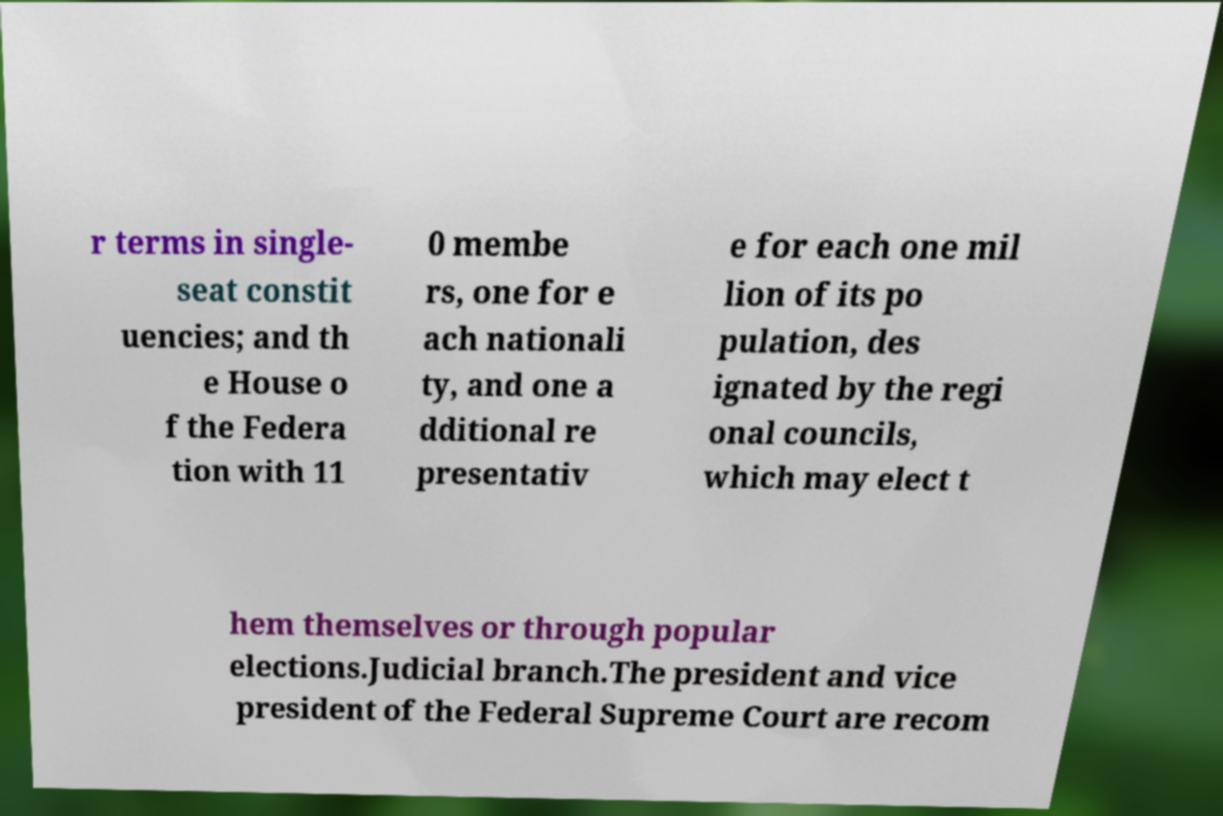Could you extract and type out the text from this image? r terms in single- seat constit uencies; and th e House o f the Federa tion with 11 0 membe rs, one for e ach nationali ty, and one a dditional re presentativ e for each one mil lion of its po pulation, des ignated by the regi onal councils, which may elect t hem themselves or through popular elections.Judicial branch.The president and vice president of the Federal Supreme Court are recom 